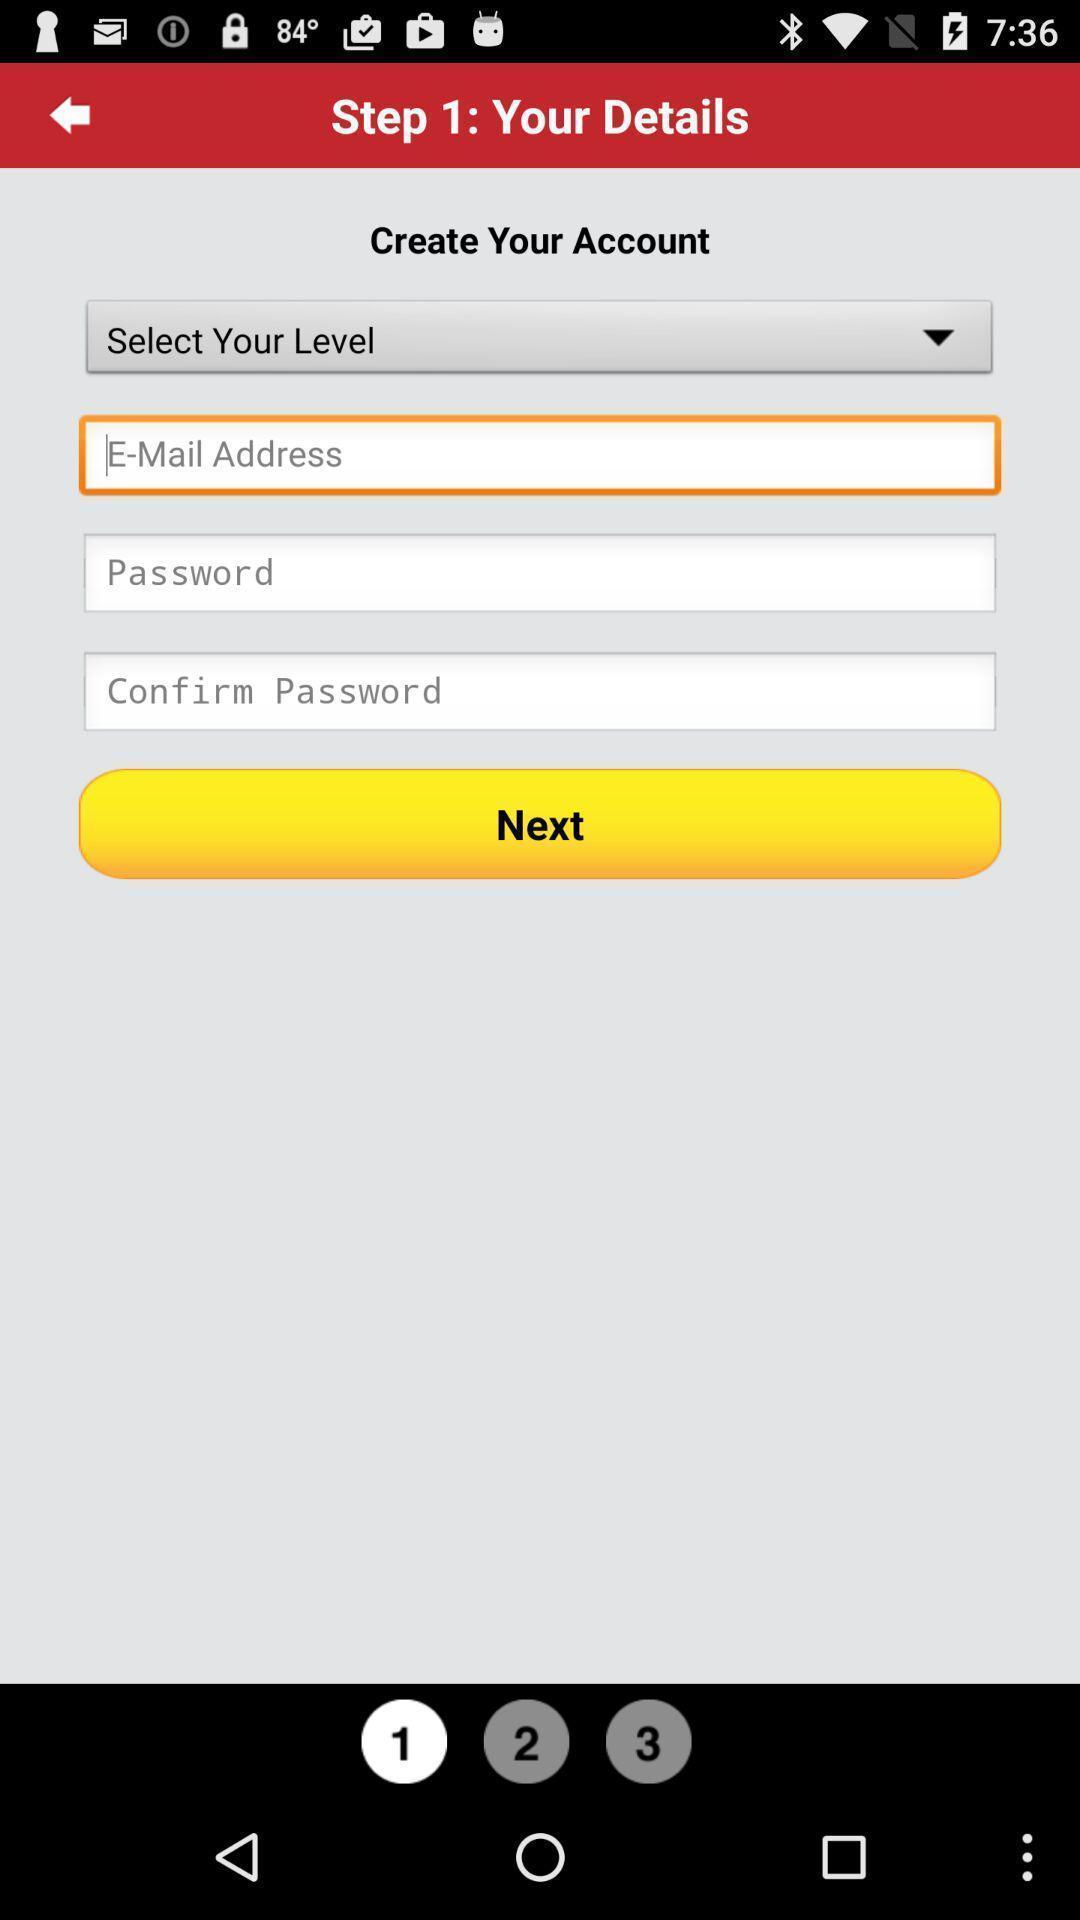Provide a detailed account of this screenshot. Page to create an account. 